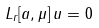Convert formula to latex. <formula><loc_0><loc_0><loc_500><loc_500>L _ { r } [ a , \mu ] \, u = 0</formula> 